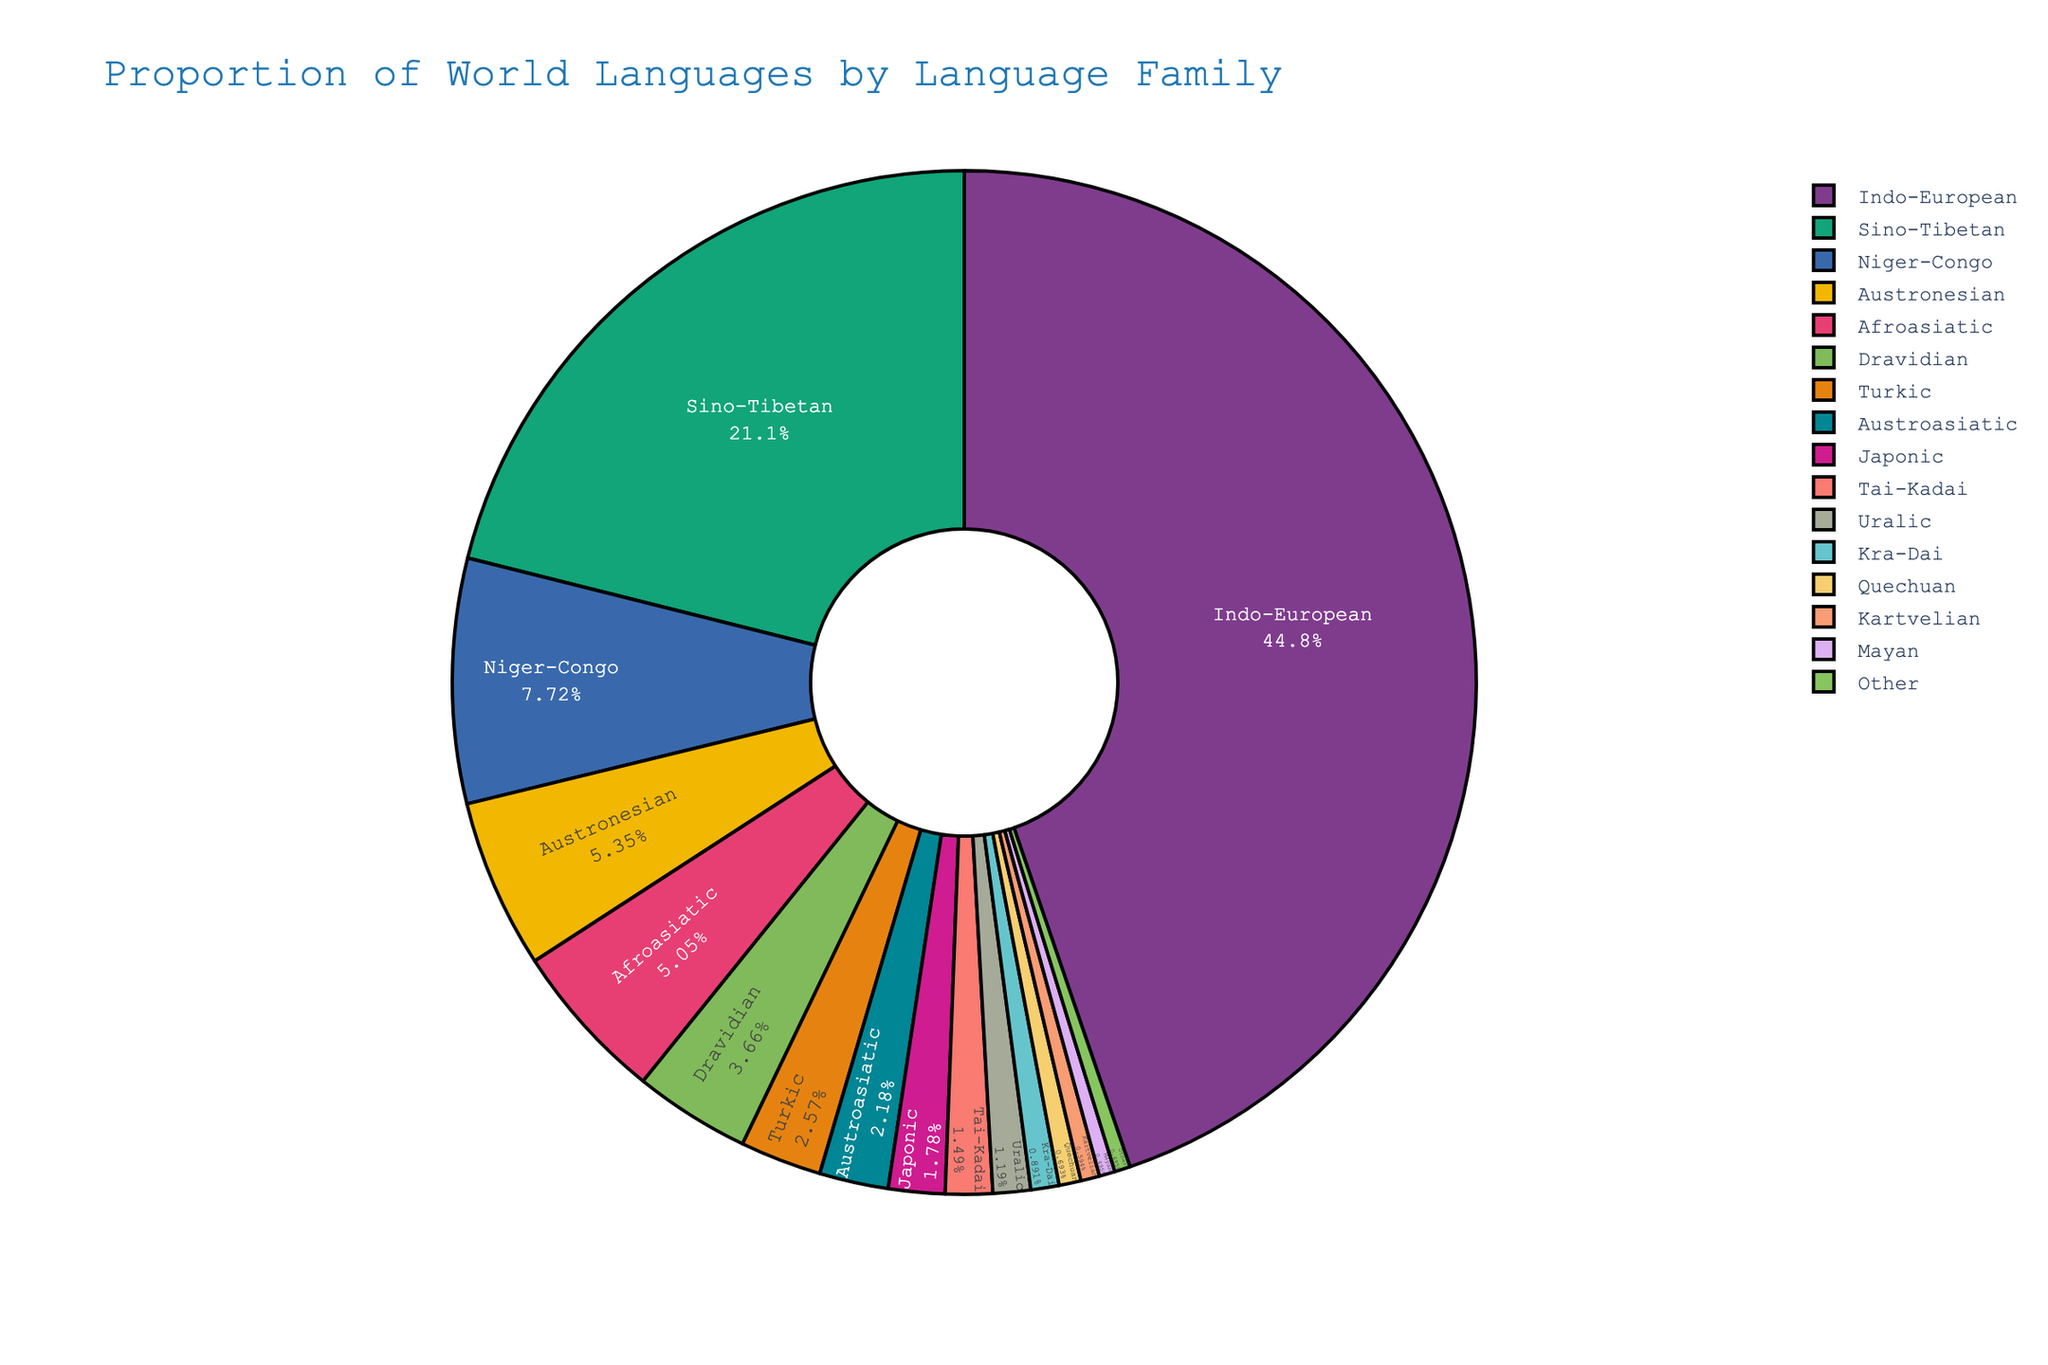What is the combined percentage of Indo-European and Sino-Tibetan language families? Add the percentages of Indo-European (45.2) and Sino-Tibetan (21.3). The sum is 45.2 + 21.3 = 66.5.
Answer: 66.5 Which language family has a larger proportion, Austronesian or Afroasiatic? Compare the percentages of Austronesian (5.4) and Afroasiatic (5.1). Austronesian has a higher percentage than Afroasiatic.
Answer: Austronesian What fraction of the pie chart is Turkic language family? The Turkic language family has a percentage of 2.6. Convert the percentage to a fraction by dividing by 100: 2.6 / 100 = 0.026.
Answer: 0.026 What is the difference in percentage points between Niger-Congo and Dravidian language families? Subtract the percentage of Dravidian (3.7) from the percentage of Niger-Congo (7.8). The difference is 7.8 - 3.7 = 4.1.
Answer: 4.1 Among Japonic, Tai-Kadai, and Uralic language families, which has the smallest proportion? Compare the percentages of Japonic (1.8), Tai-Kadai (1.5), and Uralic (1.2). Uralic has the smallest proportion.
Answer: Uralic Which language family occupies the largest segment in the pie chart? The Indo-European language family has the highest percentage (45.2), making it the largest segment in the pie chart.
Answer: Indo-European Is the proportion of the 'Other' category larger than that of Kartvelian? Compare the percentage of 'Other' (0.5) with Kartvelian (0.6). Kartvelian has a slightly higher proportion than 'Other'.
Answer: No How much smaller is the Japonic language family's proportion compared to the Afroasiatic language family's proportion? Subtract the percentage of Japonic (1.8) from Afroasiatic (5.1). The difference is 5.1 - 1.8 = 3.3.
Answer: 3.3 What is the total percentage of language families that have a proportion of 2% or more? Add the percentages of all language families with 2% or more: Indo-European (45.2), Sino-Tibetan (21.3), Niger-Congo (7.8), Austronesian (5.4), Afroasiatic (5.1), Dravidian (3.7), and Turkic (2.6). The total is 45.2 + 21.3 + 7.8 + 5.4 + 5.1 + 3.7 + 2.6 = 91.1.
Answer: 91.1 Do any language families have the same percentage? Scan through the list of percentages. Only one group 'Other' exists that has a percentage of 0.5, which coincides with Mayan.
Answer: Yes 